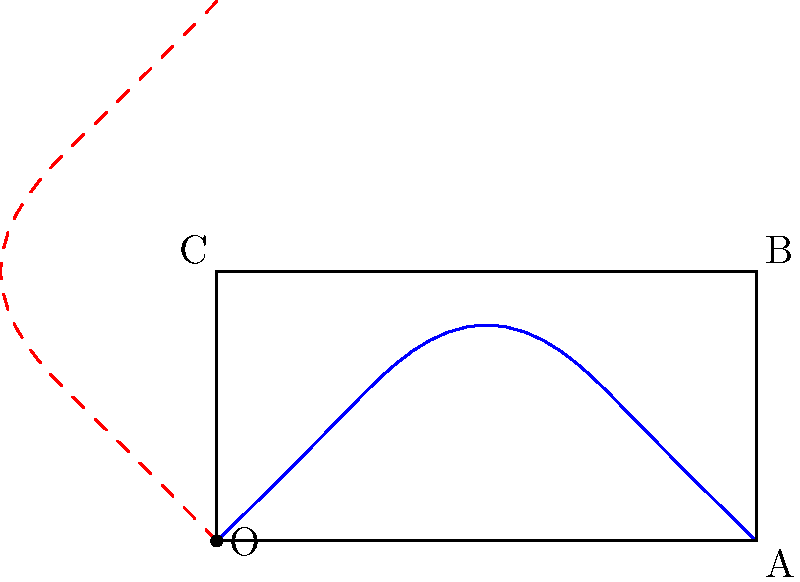A treble clef symbol is represented by the blue curve in the diagram. If this symbol is rotated 90° counterclockwise around point O, which point on the square OABC will the top of the rotated clef (shown by the red dashed curve) be closest to? To solve this problem, let's follow these steps:

1) First, we need to understand what a 90° counterclockwise rotation does:
   - It moves points from the positive x-axis to the positive y-axis.
   - Points on the y-axis move to the negative x-axis.

2) The original treble clef (blue curve) starts at O and ends at A (2,0).

3) After a 90° counterclockwise rotation:
   - The part that was at O remains at O.
   - The part that was at A (2,0) moves to (0,2), which is above point C.

4) The top of the original clef is slightly to the left of A.

5) After rotation, this top point will be slightly below the point (0,2).

6) Looking at the square OABC:
   - O is at (0,0)
   - A is at (2,0)
   - B is at (2,1)
   - C is at (0,1)

7) The rotated top of the clef (slightly below (0,2)) is closest to point C (0,1).

Therefore, the top of the rotated clef will be closest to point C.
Answer: C 